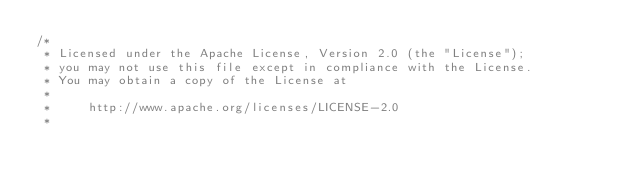Convert code to text. <code><loc_0><loc_0><loc_500><loc_500><_Java_>/*
 * Licensed under the Apache License, Version 2.0 (the "License");
 * you may not use this file except in compliance with the License.
 * You may obtain a copy of the License at
 *
 *     http://www.apache.org/licenses/LICENSE-2.0
 *</code> 